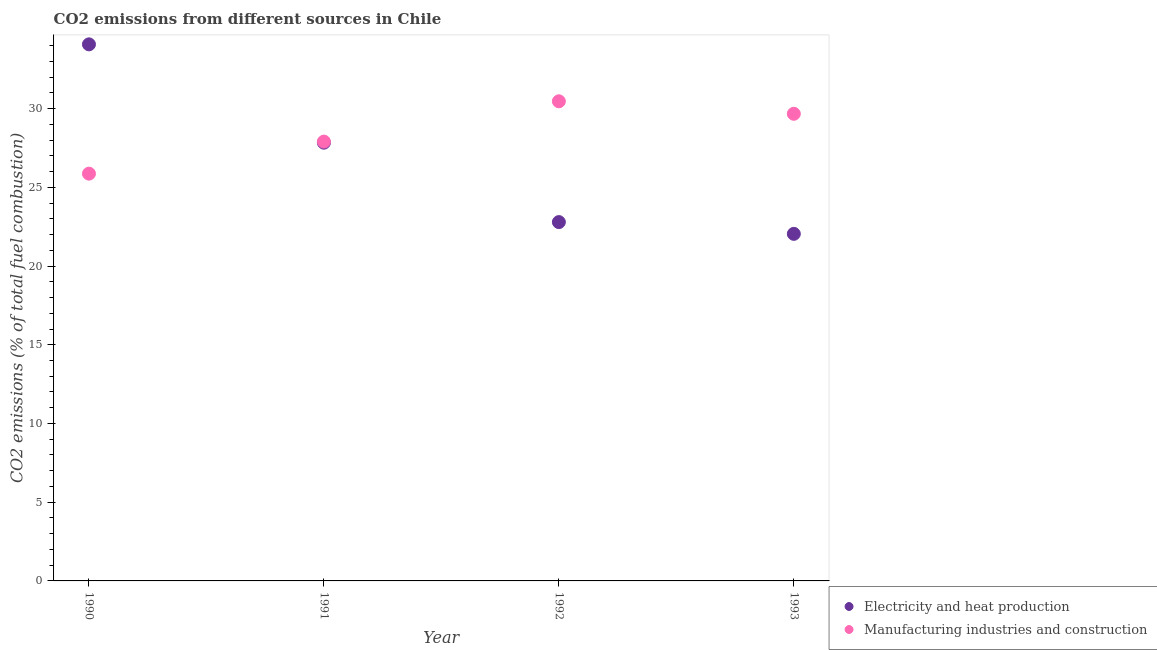How many different coloured dotlines are there?
Ensure brevity in your answer.  2. Is the number of dotlines equal to the number of legend labels?
Provide a short and direct response. Yes. What is the co2 emissions due to electricity and heat production in 1990?
Provide a short and direct response. 34.08. Across all years, what is the maximum co2 emissions due to manufacturing industries?
Your answer should be very brief. 30.46. Across all years, what is the minimum co2 emissions due to electricity and heat production?
Provide a short and direct response. 22.04. In which year was the co2 emissions due to electricity and heat production maximum?
Give a very brief answer. 1990. In which year was the co2 emissions due to electricity and heat production minimum?
Provide a short and direct response. 1993. What is the total co2 emissions due to electricity and heat production in the graph?
Ensure brevity in your answer.  106.75. What is the difference between the co2 emissions due to manufacturing industries in 1992 and that in 1993?
Make the answer very short. 0.79. What is the difference between the co2 emissions due to electricity and heat production in 1992 and the co2 emissions due to manufacturing industries in 1991?
Give a very brief answer. -5.11. What is the average co2 emissions due to manufacturing industries per year?
Provide a succinct answer. 28.48. In the year 1992, what is the difference between the co2 emissions due to manufacturing industries and co2 emissions due to electricity and heat production?
Keep it short and to the point. 7.67. What is the ratio of the co2 emissions due to electricity and heat production in 1990 to that in 1992?
Offer a terse response. 1.5. What is the difference between the highest and the second highest co2 emissions due to electricity and heat production?
Give a very brief answer. 6.24. What is the difference between the highest and the lowest co2 emissions due to manufacturing industries?
Offer a terse response. 4.59. Is the sum of the co2 emissions due to manufacturing industries in 1991 and 1992 greater than the maximum co2 emissions due to electricity and heat production across all years?
Offer a very short reply. Yes. Does the co2 emissions due to manufacturing industries monotonically increase over the years?
Provide a succinct answer. No. Is the co2 emissions due to manufacturing industries strictly less than the co2 emissions due to electricity and heat production over the years?
Provide a short and direct response. No. How many years are there in the graph?
Your answer should be very brief. 4. Does the graph contain any zero values?
Provide a short and direct response. No. Where does the legend appear in the graph?
Make the answer very short. Bottom right. How many legend labels are there?
Offer a very short reply. 2. How are the legend labels stacked?
Offer a very short reply. Vertical. What is the title of the graph?
Make the answer very short. CO2 emissions from different sources in Chile. What is the label or title of the X-axis?
Offer a terse response. Year. What is the label or title of the Y-axis?
Offer a very short reply. CO2 emissions (% of total fuel combustion). What is the CO2 emissions (% of total fuel combustion) in Electricity and heat production in 1990?
Make the answer very short. 34.08. What is the CO2 emissions (% of total fuel combustion) in Manufacturing industries and construction in 1990?
Provide a short and direct response. 25.87. What is the CO2 emissions (% of total fuel combustion) in Electricity and heat production in 1991?
Keep it short and to the point. 27.84. What is the CO2 emissions (% of total fuel combustion) in Manufacturing industries and construction in 1991?
Make the answer very short. 27.9. What is the CO2 emissions (% of total fuel combustion) of Electricity and heat production in 1992?
Keep it short and to the point. 22.79. What is the CO2 emissions (% of total fuel combustion) of Manufacturing industries and construction in 1992?
Offer a very short reply. 30.46. What is the CO2 emissions (% of total fuel combustion) in Electricity and heat production in 1993?
Offer a very short reply. 22.04. What is the CO2 emissions (% of total fuel combustion) in Manufacturing industries and construction in 1993?
Your answer should be compact. 29.67. Across all years, what is the maximum CO2 emissions (% of total fuel combustion) of Electricity and heat production?
Your response must be concise. 34.08. Across all years, what is the maximum CO2 emissions (% of total fuel combustion) of Manufacturing industries and construction?
Offer a terse response. 30.46. Across all years, what is the minimum CO2 emissions (% of total fuel combustion) of Electricity and heat production?
Offer a very short reply. 22.04. Across all years, what is the minimum CO2 emissions (% of total fuel combustion) in Manufacturing industries and construction?
Make the answer very short. 25.87. What is the total CO2 emissions (% of total fuel combustion) in Electricity and heat production in the graph?
Offer a very short reply. 106.75. What is the total CO2 emissions (% of total fuel combustion) in Manufacturing industries and construction in the graph?
Offer a very short reply. 113.9. What is the difference between the CO2 emissions (% of total fuel combustion) of Electricity and heat production in 1990 and that in 1991?
Offer a terse response. 6.24. What is the difference between the CO2 emissions (% of total fuel combustion) of Manufacturing industries and construction in 1990 and that in 1991?
Ensure brevity in your answer.  -2.03. What is the difference between the CO2 emissions (% of total fuel combustion) of Electricity and heat production in 1990 and that in 1992?
Your answer should be very brief. 11.29. What is the difference between the CO2 emissions (% of total fuel combustion) in Manufacturing industries and construction in 1990 and that in 1992?
Your response must be concise. -4.59. What is the difference between the CO2 emissions (% of total fuel combustion) of Electricity and heat production in 1990 and that in 1993?
Offer a terse response. 12.04. What is the difference between the CO2 emissions (% of total fuel combustion) in Manufacturing industries and construction in 1990 and that in 1993?
Offer a very short reply. -3.8. What is the difference between the CO2 emissions (% of total fuel combustion) in Electricity and heat production in 1991 and that in 1992?
Provide a succinct answer. 5.05. What is the difference between the CO2 emissions (% of total fuel combustion) in Manufacturing industries and construction in 1991 and that in 1992?
Keep it short and to the point. -2.56. What is the difference between the CO2 emissions (% of total fuel combustion) in Electricity and heat production in 1991 and that in 1993?
Your answer should be very brief. 5.79. What is the difference between the CO2 emissions (% of total fuel combustion) in Manufacturing industries and construction in 1991 and that in 1993?
Provide a succinct answer. -1.77. What is the difference between the CO2 emissions (% of total fuel combustion) of Electricity and heat production in 1992 and that in 1993?
Offer a terse response. 0.75. What is the difference between the CO2 emissions (% of total fuel combustion) of Manufacturing industries and construction in 1992 and that in 1993?
Your answer should be compact. 0.79. What is the difference between the CO2 emissions (% of total fuel combustion) in Electricity and heat production in 1990 and the CO2 emissions (% of total fuel combustion) in Manufacturing industries and construction in 1991?
Your answer should be compact. 6.18. What is the difference between the CO2 emissions (% of total fuel combustion) in Electricity and heat production in 1990 and the CO2 emissions (% of total fuel combustion) in Manufacturing industries and construction in 1992?
Make the answer very short. 3.62. What is the difference between the CO2 emissions (% of total fuel combustion) of Electricity and heat production in 1990 and the CO2 emissions (% of total fuel combustion) of Manufacturing industries and construction in 1993?
Give a very brief answer. 4.41. What is the difference between the CO2 emissions (% of total fuel combustion) of Electricity and heat production in 1991 and the CO2 emissions (% of total fuel combustion) of Manufacturing industries and construction in 1992?
Keep it short and to the point. -2.63. What is the difference between the CO2 emissions (% of total fuel combustion) of Electricity and heat production in 1991 and the CO2 emissions (% of total fuel combustion) of Manufacturing industries and construction in 1993?
Ensure brevity in your answer.  -1.83. What is the difference between the CO2 emissions (% of total fuel combustion) of Electricity and heat production in 1992 and the CO2 emissions (% of total fuel combustion) of Manufacturing industries and construction in 1993?
Offer a terse response. -6.88. What is the average CO2 emissions (% of total fuel combustion) of Electricity and heat production per year?
Your answer should be very brief. 26.69. What is the average CO2 emissions (% of total fuel combustion) of Manufacturing industries and construction per year?
Keep it short and to the point. 28.48. In the year 1990, what is the difference between the CO2 emissions (% of total fuel combustion) of Electricity and heat production and CO2 emissions (% of total fuel combustion) of Manufacturing industries and construction?
Offer a very short reply. 8.21. In the year 1991, what is the difference between the CO2 emissions (% of total fuel combustion) of Electricity and heat production and CO2 emissions (% of total fuel combustion) of Manufacturing industries and construction?
Provide a succinct answer. -0.07. In the year 1992, what is the difference between the CO2 emissions (% of total fuel combustion) of Electricity and heat production and CO2 emissions (% of total fuel combustion) of Manufacturing industries and construction?
Your answer should be compact. -7.67. In the year 1993, what is the difference between the CO2 emissions (% of total fuel combustion) in Electricity and heat production and CO2 emissions (% of total fuel combustion) in Manufacturing industries and construction?
Make the answer very short. -7.63. What is the ratio of the CO2 emissions (% of total fuel combustion) in Electricity and heat production in 1990 to that in 1991?
Provide a succinct answer. 1.22. What is the ratio of the CO2 emissions (% of total fuel combustion) of Manufacturing industries and construction in 1990 to that in 1991?
Your response must be concise. 0.93. What is the ratio of the CO2 emissions (% of total fuel combustion) of Electricity and heat production in 1990 to that in 1992?
Your response must be concise. 1.5. What is the ratio of the CO2 emissions (% of total fuel combustion) in Manufacturing industries and construction in 1990 to that in 1992?
Your answer should be very brief. 0.85. What is the ratio of the CO2 emissions (% of total fuel combustion) in Electricity and heat production in 1990 to that in 1993?
Offer a very short reply. 1.55. What is the ratio of the CO2 emissions (% of total fuel combustion) of Manufacturing industries and construction in 1990 to that in 1993?
Give a very brief answer. 0.87. What is the ratio of the CO2 emissions (% of total fuel combustion) in Electricity and heat production in 1991 to that in 1992?
Provide a succinct answer. 1.22. What is the ratio of the CO2 emissions (% of total fuel combustion) of Manufacturing industries and construction in 1991 to that in 1992?
Your answer should be compact. 0.92. What is the ratio of the CO2 emissions (% of total fuel combustion) in Electricity and heat production in 1991 to that in 1993?
Offer a terse response. 1.26. What is the ratio of the CO2 emissions (% of total fuel combustion) in Manufacturing industries and construction in 1991 to that in 1993?
Provide a succinct answer. 0.94. What is the ratio of the CO2 emissions (% of total fuel combustion) in Electricity and heat production in 1992 to that in 1993?
Make the answer very short. 1.03. What is the ratio of the CO2 emissions (% of total fuel combustion) of Manufacturing industries and construction in 1992 to that in 1993?
Provide a short and direct response. 1.03. What is the difference between the highest and the second highest CO2 emissions (% of total fuel combustion) in Electricity and heat production?
Keep it short and to the point. 6.24. What is the difference between the highest and the second highest CO2 emissions (% of total fuel combustion) in Manufacturing industries and construction?
Make the answer very short. 0.79. What is the difference between the highest and the lowest CO2 emissions (% of total fuel combustion) in Electricity and heat production?
Ensure brevity in your answer.  12.04. What is the difference between the highest and the lowest CO2 emissions (% of total fuel combustion) in Manufacturing industries and construction?
Ensure brevity in your answer.  4.59. 